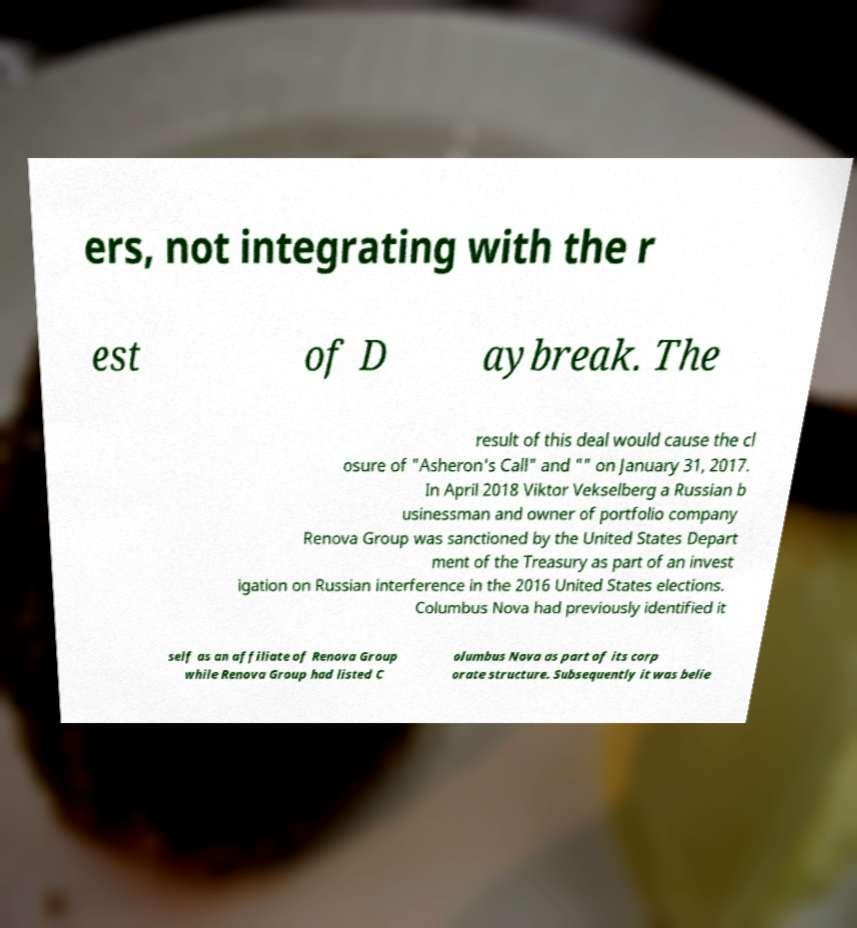Please read and relay the text visible in this image. What does it say? ers, not integrating with the r est of D aybreak. The result of this deal would cause the cl osure of "Asheron's Call" and "" on January 31, 2017. In April 2018 Viktor Vekselberg a Russian b usinessman and owner of portfolio company Renova Group was sanctioned by the United States Depart ment of the Treasury as part of an invest igation on Russian interference in the 2016 United States elections. Columbus Nova had previously identified it self as an affiliate of Renova Group while Renova Group had listed C olumbus Nova as part of its corp orate structure. Subsequently it was belie 